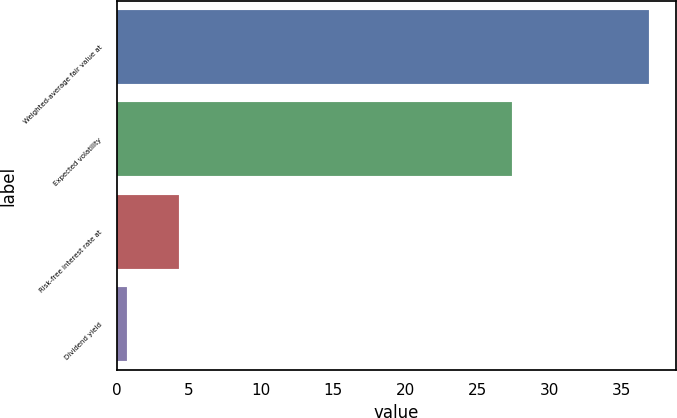<chart> <loc_0><loc_0><loc_500><loc_500><bar_chart><fcel>Weighted-average fair value at<fcel>Expected volatility<fcel>Risk-free interest rate at<fcel>Dividend yield<nl><fcel>36.91<fcel>27.4<fcel>4.32<fcel>0.7<nl></chart> 